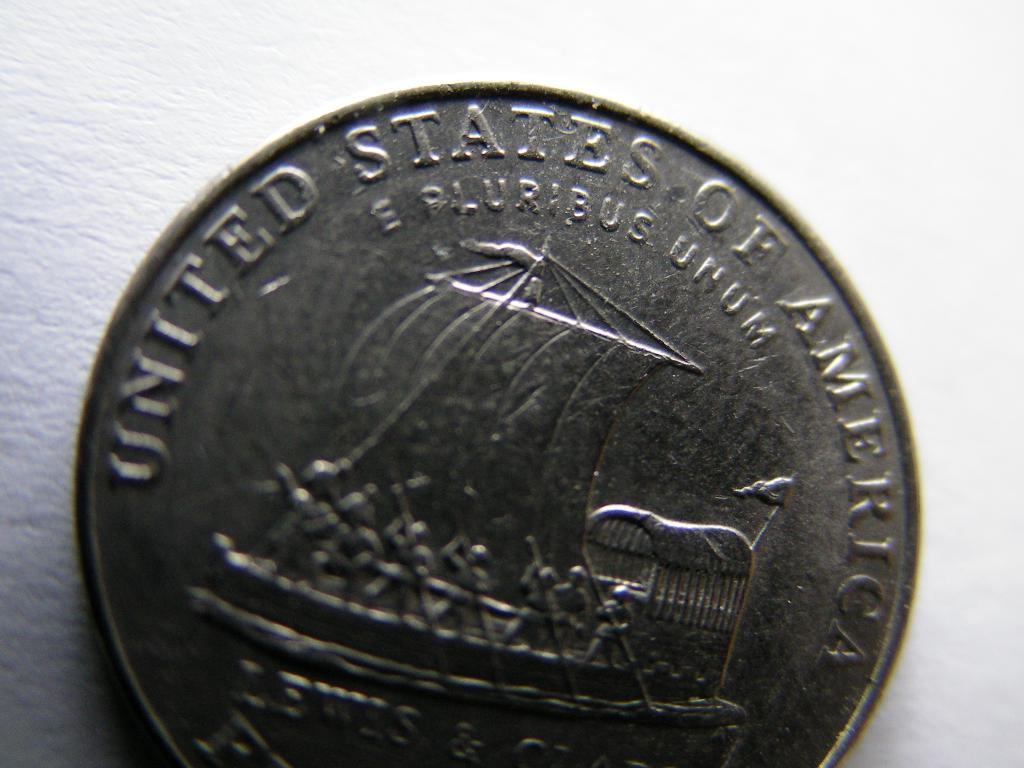Where was this coin made?
Give a very brief answer. United states of america. What phrase is written in latin?
Your response must be concise. E pluribus unum. 